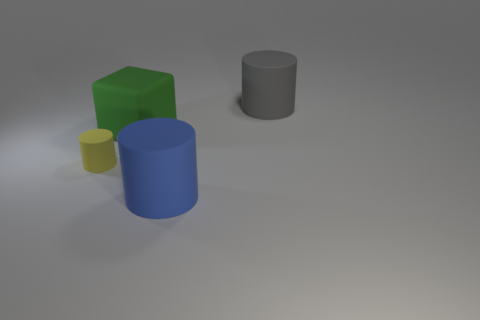What materials do the objects in the image appear to be made of? The objects seem to have a matte finish with little to no reflection, suggesting a possible construction from a non-glossy plastic or a similarly textured material. 